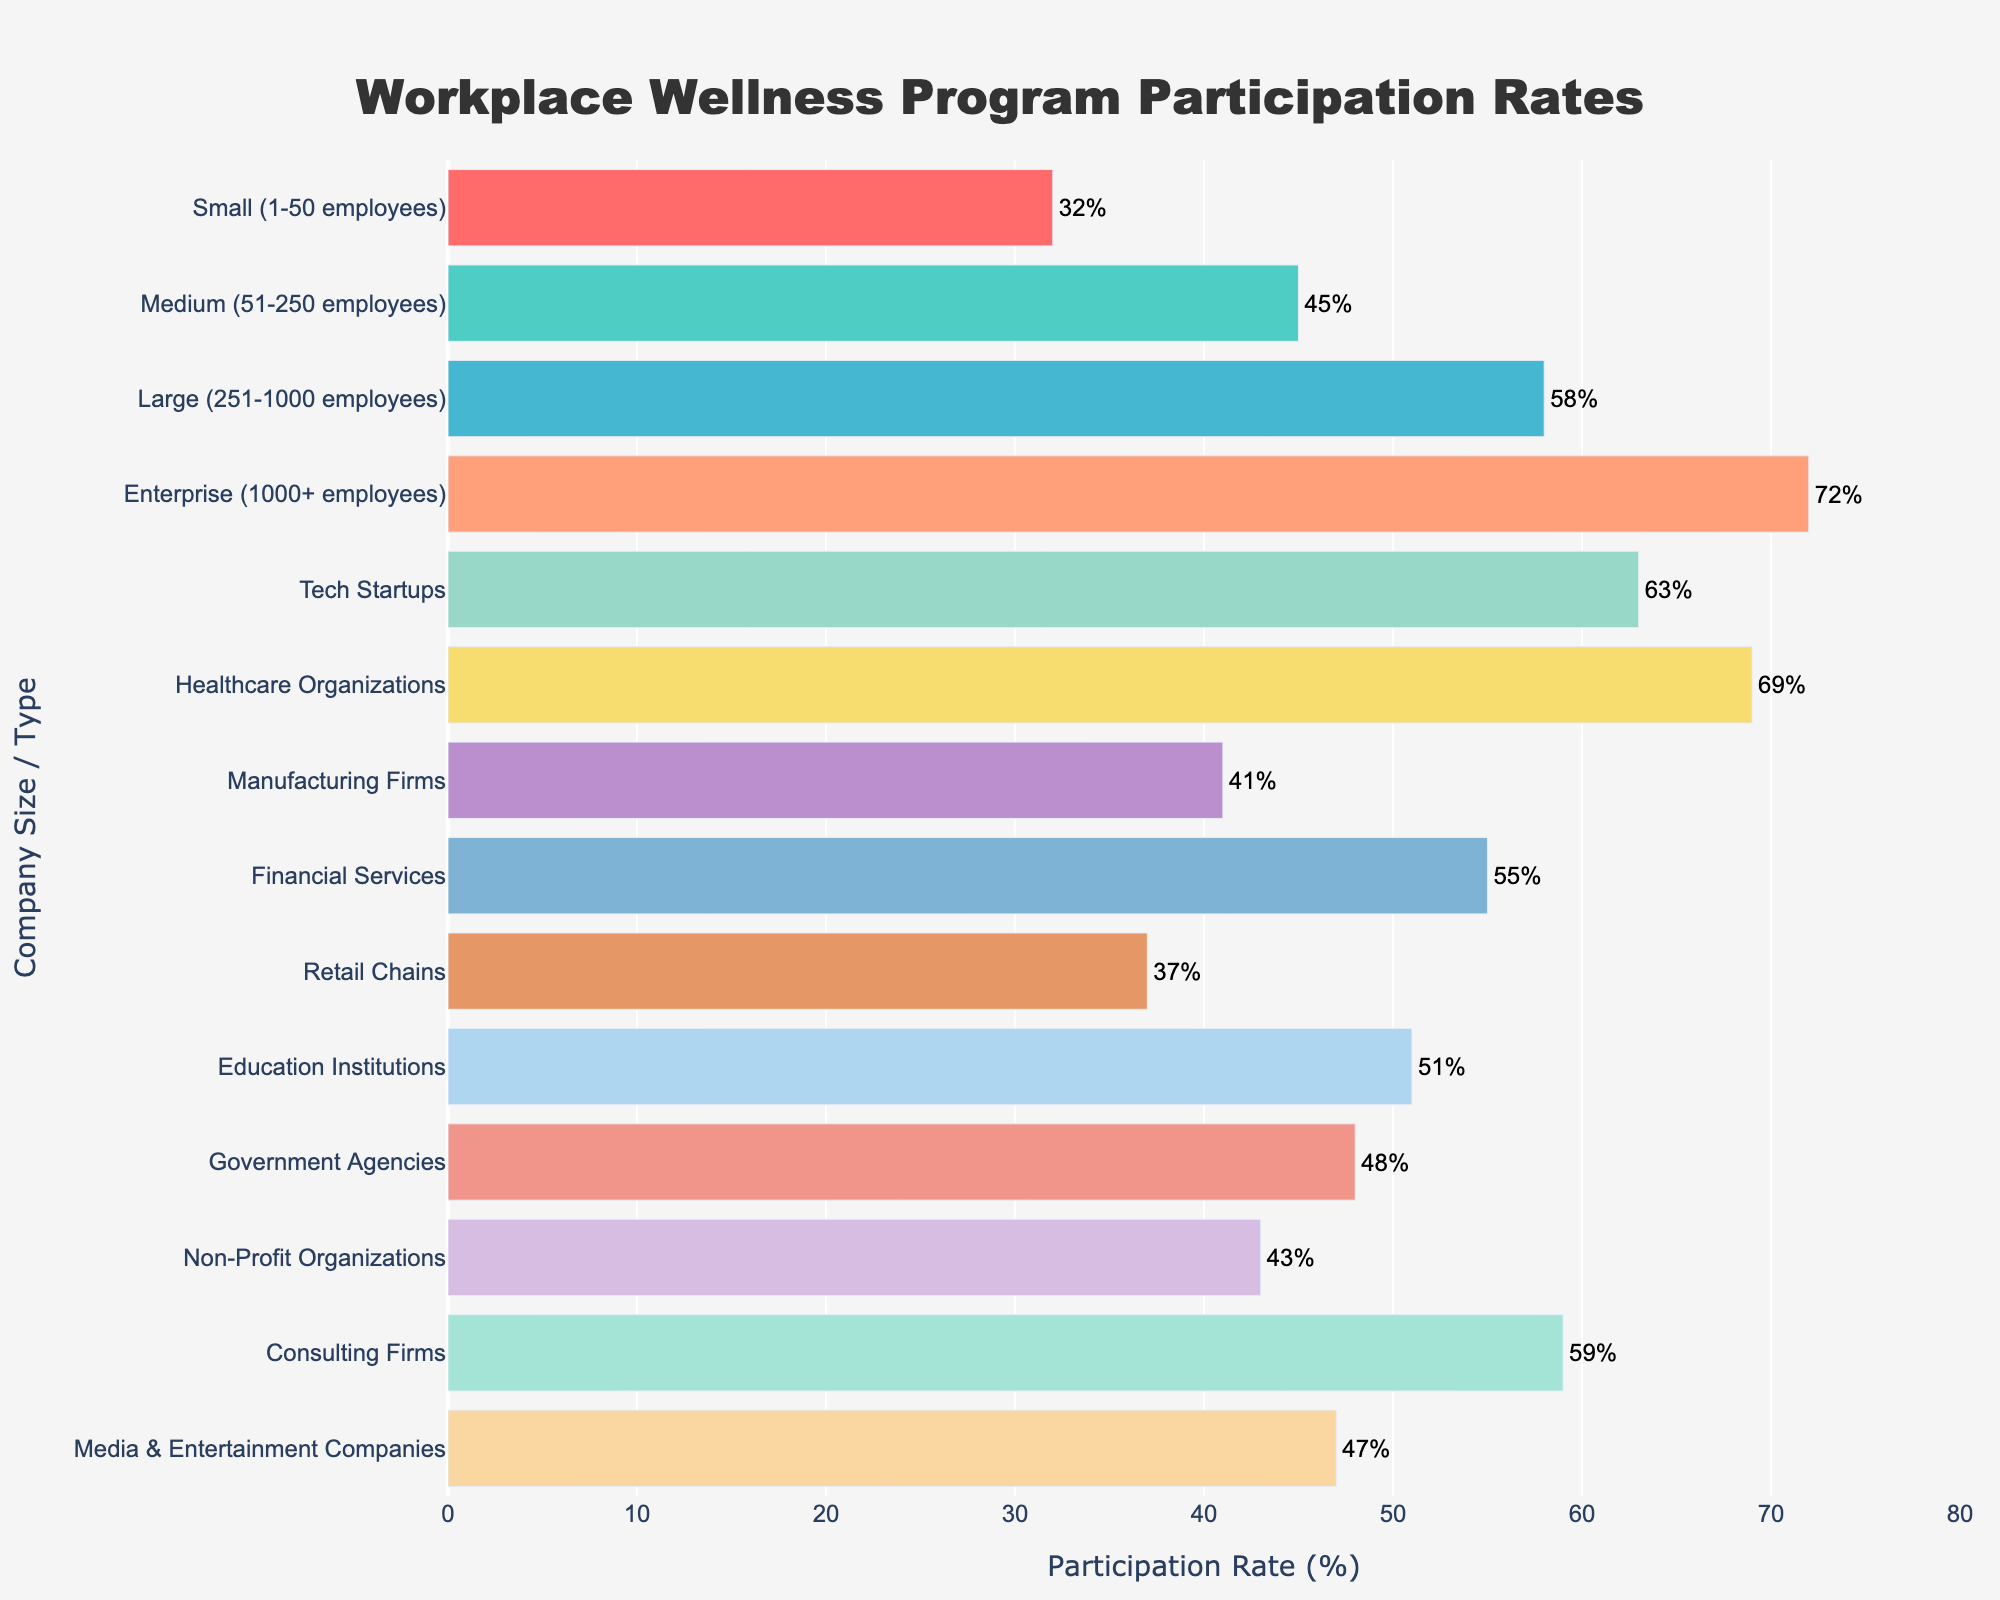Which company size/type has the highest workplace wellness program participation rate? The bar chart shows various company sizes/types along with their corresponding participation rates. By looking at the tallest bar, it is clear that "Enterprise (1000+ employees)" has the highest participation rate of 72%.
Answer: "Enterprise (1000+ employees)" What is the difference in wellness program participation rates between Tech Startups and Retail Chains? According to the bar chart, Tech Startups have a participation rate of 63% and Retail Chains have a rate of 37%. Subtracting 37 from 63 gives 26.
Answer: 26 How many company sizes/types have participation rates above 50%? By visually examining the bars, the company sizes/types with participation rates above 50% are: Large (251-1000 employees), Enterprise (1000+ employees), Tech Startups, Healthcare Organizations, Financial Services, Education Institutions, and Consulting Firms. Counting these gives 7.
Answer: 7 Which has a higher participation rate: Government Agencies or Media & Entertainment Companies? By comparing the heights of the bars for Government Agencies and Media & Entertainment Companies, it is clear that Government Agencies have a participation rate of 48%, which is higher than Media & Entertainment Companies' 47%.
Answer: Government Agencies What is the average participation rate for Non-Profit Organizations, Consulting Firms, and Manufacturing Firms? The participation rates are 43% for Non-Profit Organizations, 59% for Consulting Firms, and 41% for Manufacturing Firms. Summing these gives 143, and dividing by 3 gives an average of 47.67%.
Answer: 47.67% Which visual attribute distinguishes the company sizes/types with participation rates above 60%? The bars for company sizes/types with participation rates above 60% (Enterprise, Tech Startups, and Healthcare Organizations) are visibly longer and extend beyond the 60% mark on the x-axis.
Answer: Longer bars beyond 60% mark What is the lowest participation rate and which company size/type does it correspond to? By looking at the shortest bar on the chart, it corresponds to "Small (1-50 employees)" with a participation rate of 32%.
Answer: 32%, Small (1-50 employees) Do more company sizes/types have participation rates greater than or less than 50%? Counting the bars above and below the 50% mark, there are 7 bars above and 7 bars below 50%. Therefore, the numbers are equal.
Answer: Equal What is the participation rate range (difference between highest and lowest rates)? The highest participation rate is 72% (Enterprise) and the lowest is 32% (Small). The range is calculated by subtracting 32 from 72, which gives 40.
Answer: 40 Is the participation rate of Education Institutions closer to that of Government Agencies or Financial Services? Education Institutions have a participation rate of 51%, Government Agencies have 48%, and Financial Services have 55%. The difference from Education Institutions' rate is 3 for Government Agencies and 4 for Financial Services, making it closer to Government Agencies.
Answer: Government Agencies 